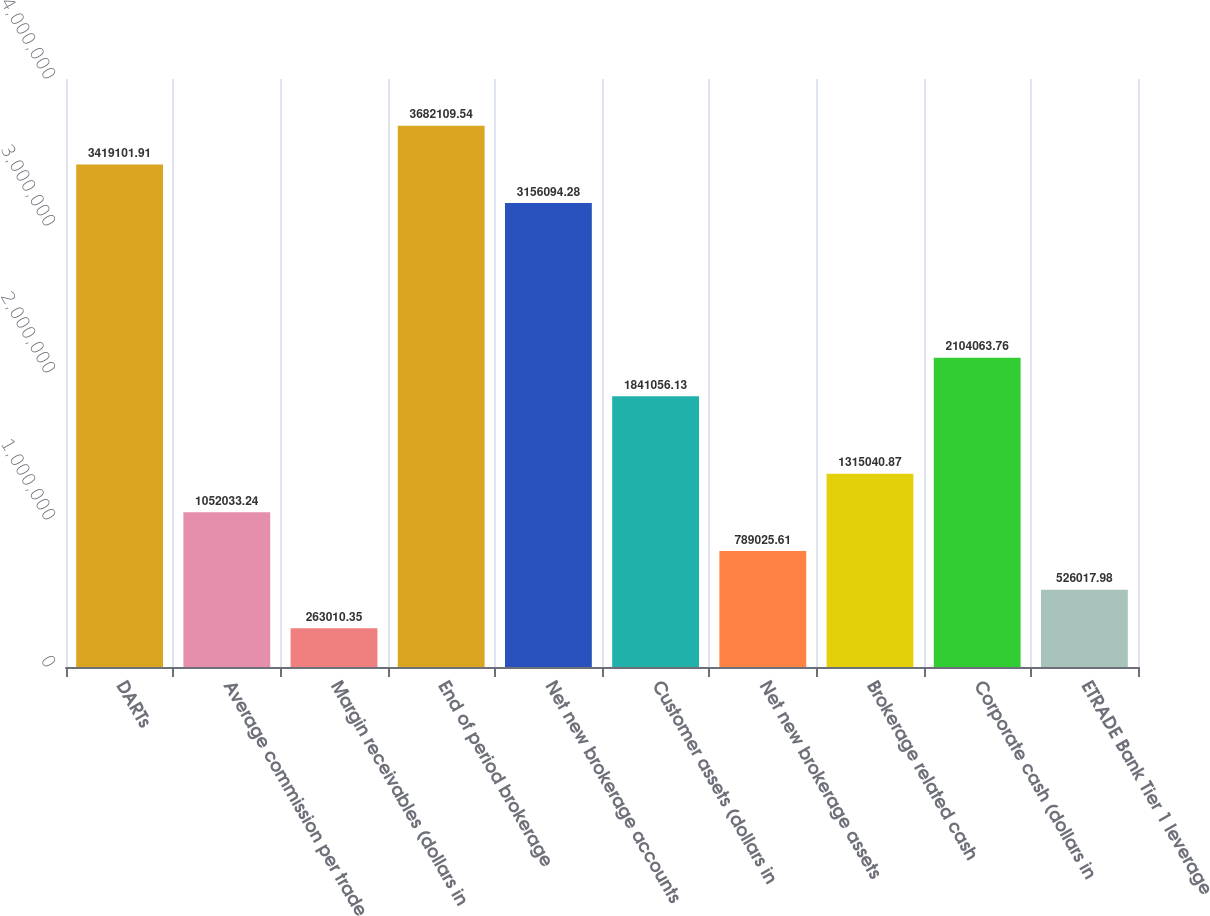Convert chart. <chart><loc_0><loc_0><loc_500><loc_500><bar_chart><fcel>DARTs<fcel>Average commission per trade<fcel>Margin receivables (dollars in<fcel>End of period brokerage<fcel>Net new brokerage accounts<fcel>Customer assets (dollars in<fcel>Net new brokerage assets<fcel>Brokerage related cash<fcel>Corporate cash (dollars in<fcel>ETRADE Bank Tier 1 leverage<nl><fcel>3.4191e+06<fcel>1.05203e+06<fcel>263010<fcel>3.68211e+06<fcel>3.15609e+06<fcel>1.84106e+06<fcel>789026<fcel>1.31504e+06<fcel>2.10406e+06<fcel>526018<nl></chart> 